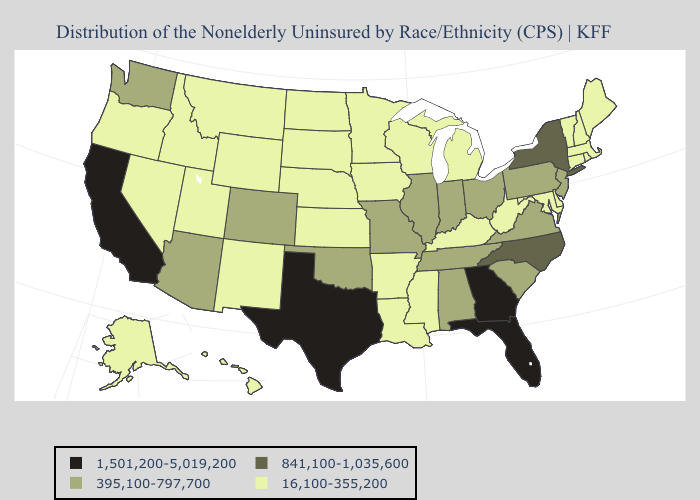Does Utah have a higher value than Arkansas?
Write a very short answer. No. Which states hav the highest value in the South?
Concise answer only. Florida, Georgia, Texas. What is the highest value in states that border Connecticut?
Quick response, please. 841,100-1,035,600. Name the states that have a value in the range 841,100-1,035,600?
Keep it brief. New York, North Carolina. What is the value of California?
Write a very short answer. 1,501,200-5,019,200. Which states have the lowest value in the USA?
Give a very brief answer. Alaska, Arkansas, Connecticut, Delaware, Hawaii, Idaho, Iowa, Kansas, Kentucky, Louisiana, Maine, Maryland, Massachusetts, Michigan, Minnesota, Mississippi, Montana, Nebraska, Nevada, New Hampshire, New Mexico, North Dakota, Oregon, Rhode Island, South Dakota, Utah, Vermont, West Virginia, Wisconsin, Wyoming. Among the states that border Louisiana , which have the lowest value?
Answer briefly. Arkansas, Mississippi. Is the legend a continuous bar?
Short answer required. No. What is the value of Idaho?
Write a very short answer. 16,100-355,200. Among the states that border North Carolina , which have the highest value?
Be succinct. Georgia. Which states hav the highest value in the Northeast?
Be succinct. New York. Which states have the lowest value in the West?
Quick response, please. Alaska, Hawaii, Idaho, Montana, Nevada, New Mexico, Oregon, Utah, Wyoming. What is the value of Illinois?
Be succinct. 395,100-797,700. What is the value of Utah?
Short answer required. 16,100-355,200. 